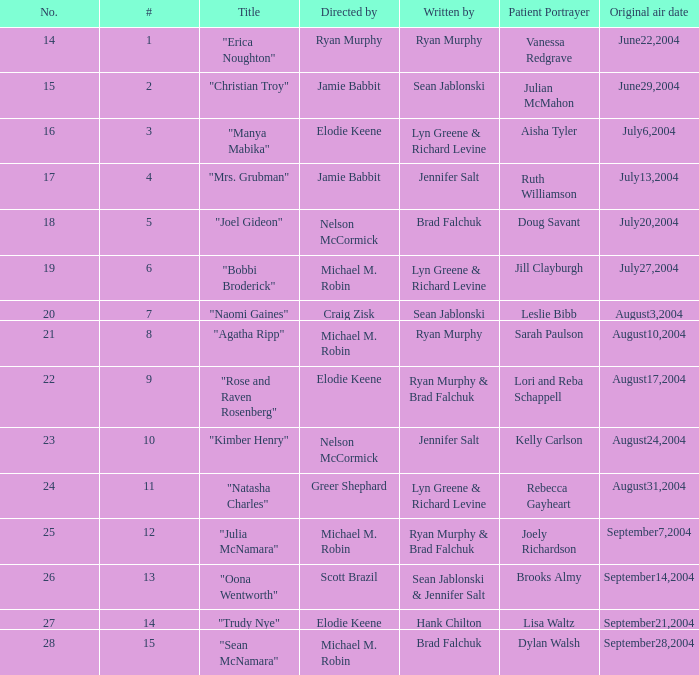How many episodes are numbered 4 in the season? 1.0. Could you help me parse every detail presented in this table? {'header': ['No.', '#', 'Title', 'Directed by', 'Written by', 'Patient Portrayer', 'Original air date'], 'rows': [['14', '1', '"Erica Noughton"', 'Ryan Murphy', 'Ryan Murphy', 'Vanessa Redgrave', 'June22,2004'], ['15', '2', '"Christian Troy"', 'Jamie Babbit', 'Sean Jablonski', 'Julian McMahon', 'June29,2004'], ['16', '3', '"Manya Mabika"', 'Elodie Keene', 'Lyn Greene & Richard Levine', 'Aisha Tyler', 'July6,2004'], ['17', '4', '"Mrs. Grubman"', 'Jamie Babbit', 'Jennifer Salt', 'Ruth Williamson', 'July13,2004'], ['18', '5', '"Joel Gideon"', 'Nelson McCormick', 'Brad Falchuk', 'Doug Savant', 'July20,2004'], ['19', '6', '"Bobbi Broderick"', 'Michael M. Robin', 'Lyn Greene & Richard Levine', 'Jill Clayburgh', 'July27,2004'], ['20', '7', '"Naomi Gaines"', 'Craig Zisk', 'Sean Jablonski', 'Leslie Bibb', 'August3,2004'], ['21', '8', '"Agatha Ripp"', 'Michael M. Robin', 'Ryan Murphy', 'Sarah Paulson', 'August10,2004'], ['22', '9', '"Rose and Raven Rosenberg"', 'Elodie Keene', 'Ryan Murphy & Brad Falchuk', 'Lori and Reba Schappell', 'August17,2004'], ['23', '10', '"Kimber Henry"', 'Nelson McCormick', 'Jennifer Salt', 'Kelly Carlson', 'August24,2004'], ['24', '11', '"Natasha Charles"', 'Greer Shephard', 'Lyn Greene & Richard Levine', 'Rebecca Gayheart', 'August31,2004'], ['25', '12', '"Julia McNamara"', 'Michael M. Robin', 'Ryan Murphy & Brad Falchuk', 'Joely Richardson', 'September7,2004'], ['26', '13', '"Oona Wentworth"', 'Scott Brazil', 'Sean Jablonski & Jennifer Salt', 'Brooks Almy', 'September14,2004'], ['27', '14', '"Trudy Nye"', 'Elodie Keene', 'Hank Chilton', 'Lisa Waltz', 'September21,2004'], ['28', '15', '"Sean McNamara"', 'Michael M. Robin', 'Brad Falchuk', 'Dylan Walsh', 'September28,2004']]} 